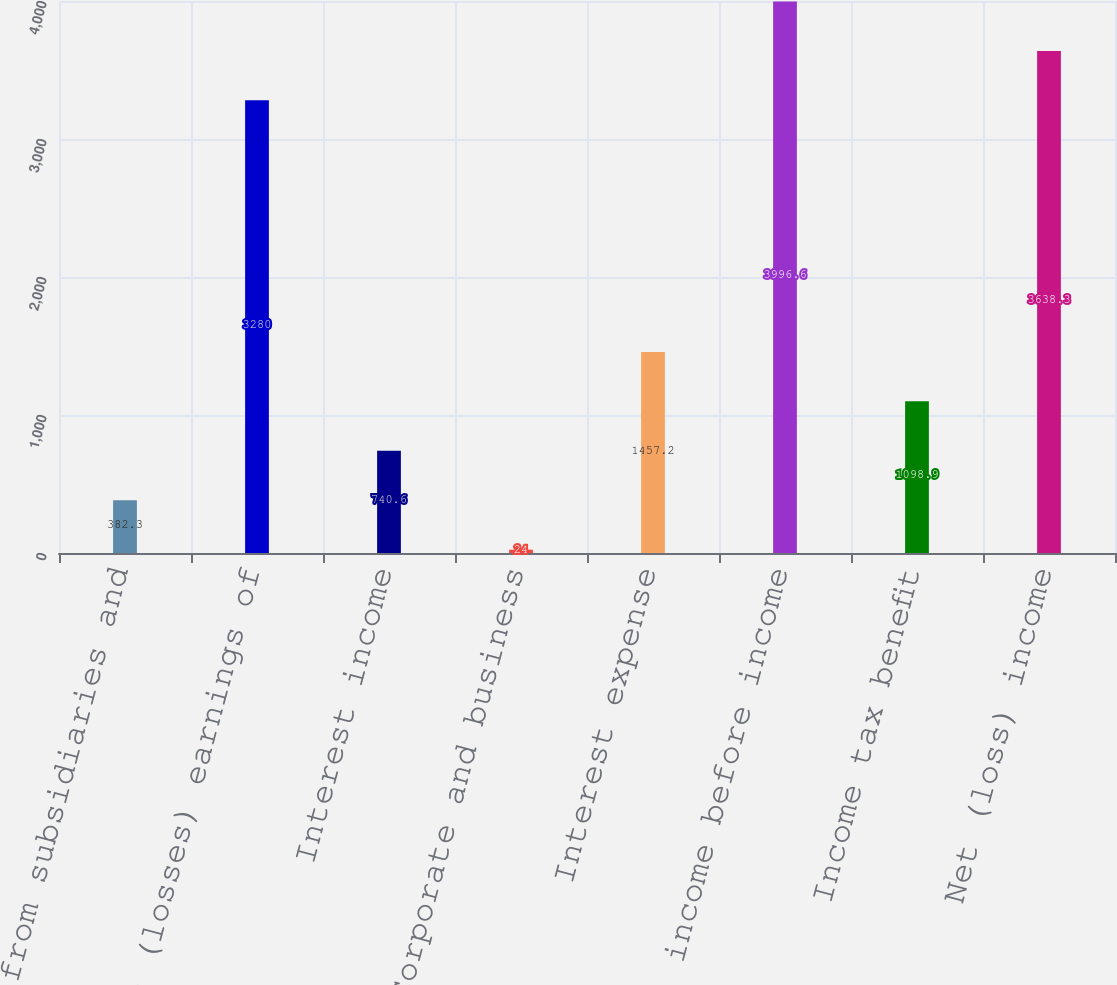<chart> <loc_0><loc_0><loc_500><loc_500><bar_chart><fcel>Revenues from subsidiaries and<fcel>Equity in (losses) earnings of<fcel>Interest income<fcel>Corporate and business<fcel>Interest expense<fcel>(Loss) income before income<fcel>Income tax benefit<fcel>Net (loss) income<nl><fcel>382.3<fcel>3280<fcel>740.6<fcel>24<fcel>1457.2<fcel>3996.6<fcel>1098.9<fcel>3638.3<nl></chart> 